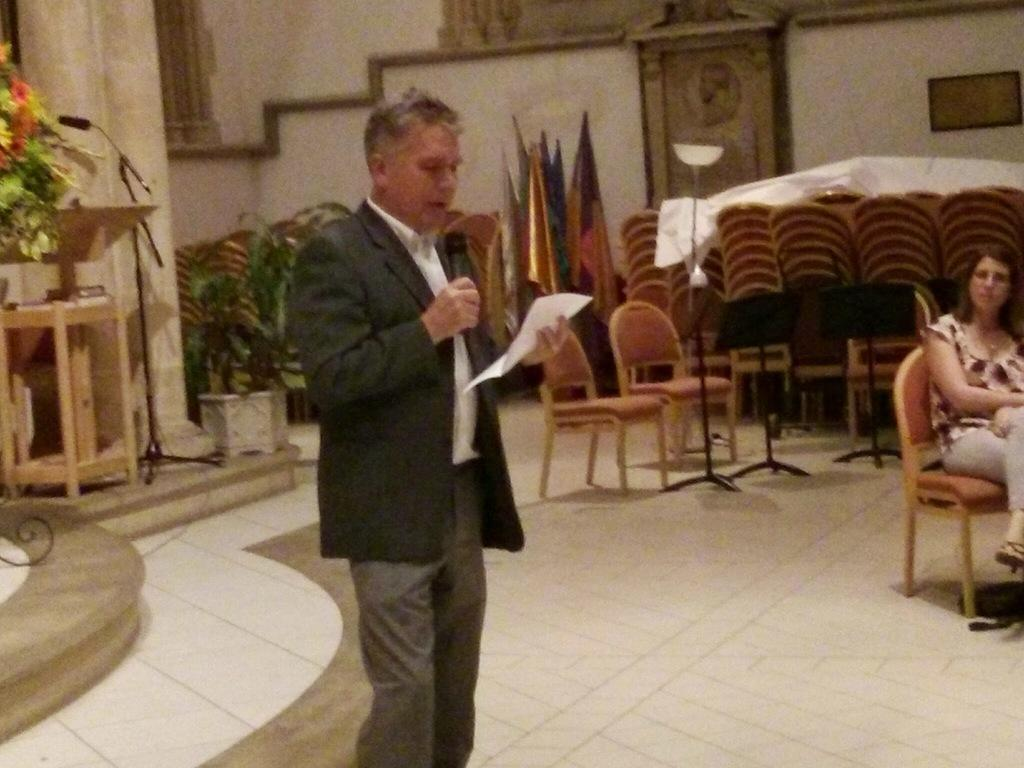What is the man in the image holding? The man is holding a mic and a paper. What is the woman in the image doing? The woman is sitting on a chair. Can you describe the man's actions in the image? The man is holding a mic and a paper, which might suggest he is about to give a speech or presentation. What type of liquid is being poured out of the woman's nerve in the image? There is no mention of liquid, nerves, or impulses in the image. The image only features a man holding a mic and a paper, and a woman sitting on a chair. 